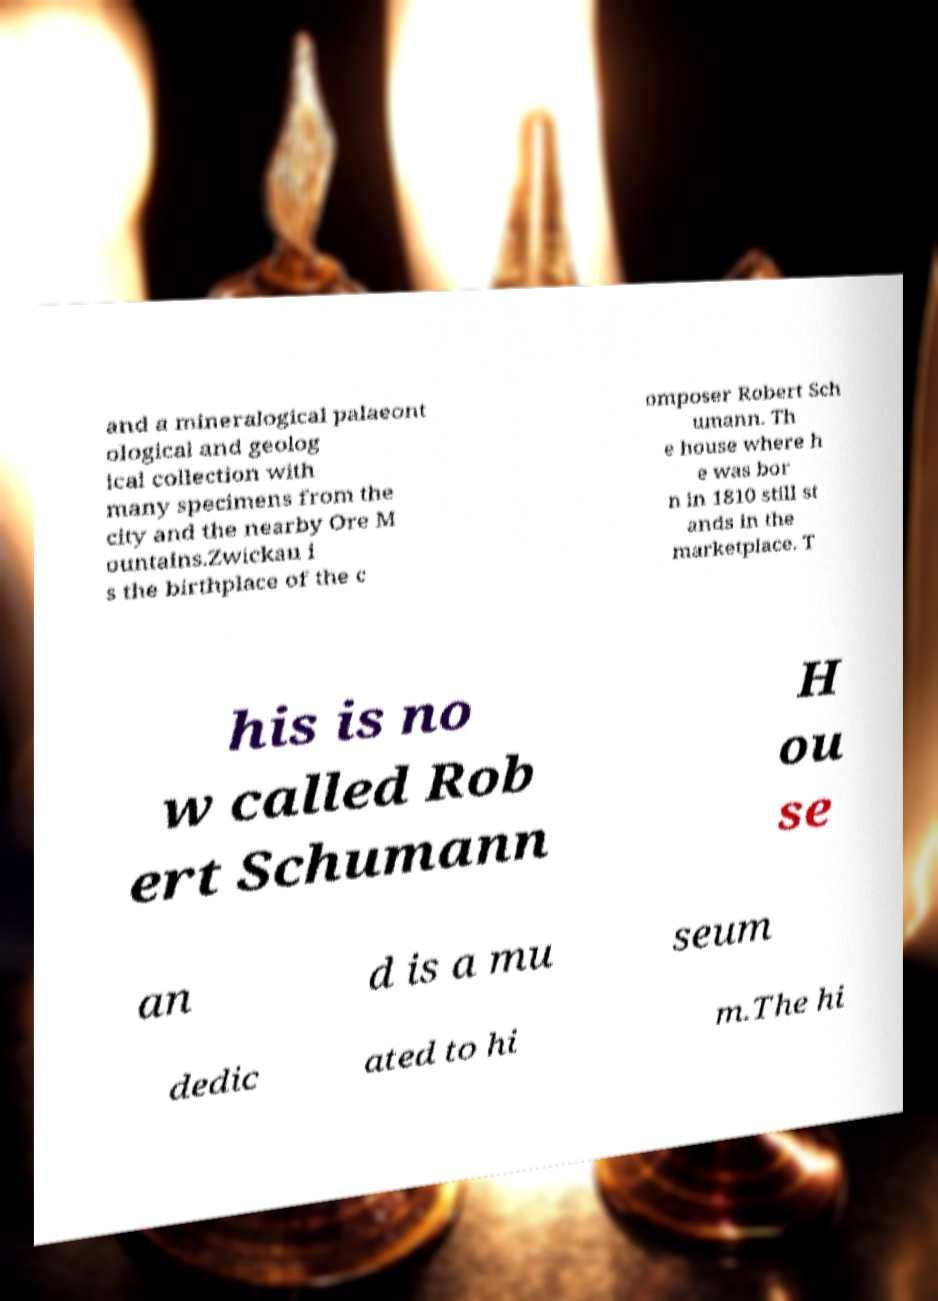Please read and relay the text visible in this image. What does it say? and a mineralogical palaeont ological and geolog ical collection with many specimens from the city and the nearby Ore M ountains.Zwickau i s the birthplace of the c omposer Robert Sch umann. Th e house where h e was bor n in 1810 still st ands in the marketplace. T his is no w called Rob ert Schumann H ou se an d is a mu seum dedic ated to hi m.The hi 